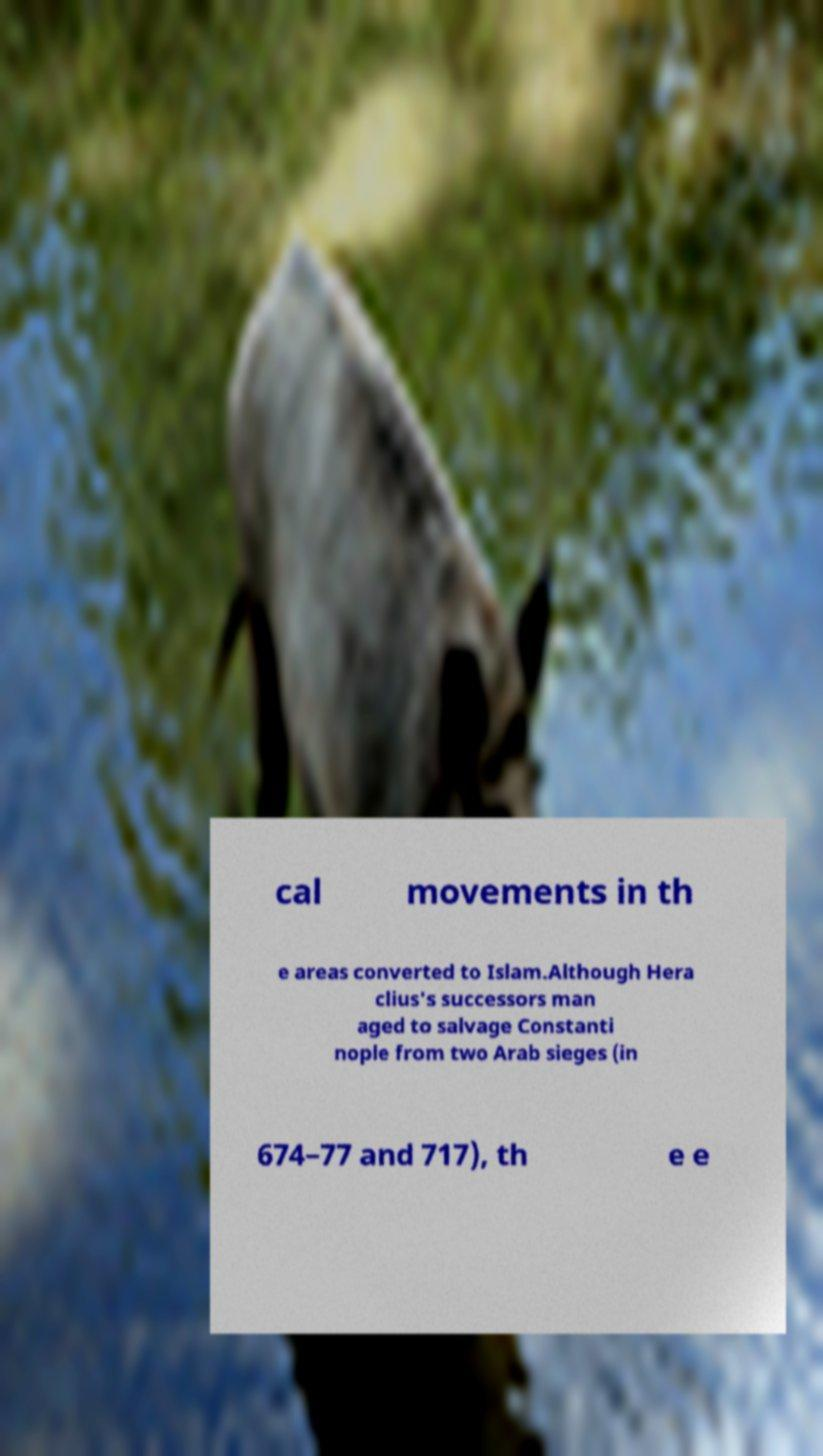For documentation purposes, I need the text within this image transcribed. Could you provide that? cal movements in th e areas converted to Islam.Although Hera clius's successors man aged to salvage Constanti nople from two Arab sieges (in 674–77 and 717), th e e 